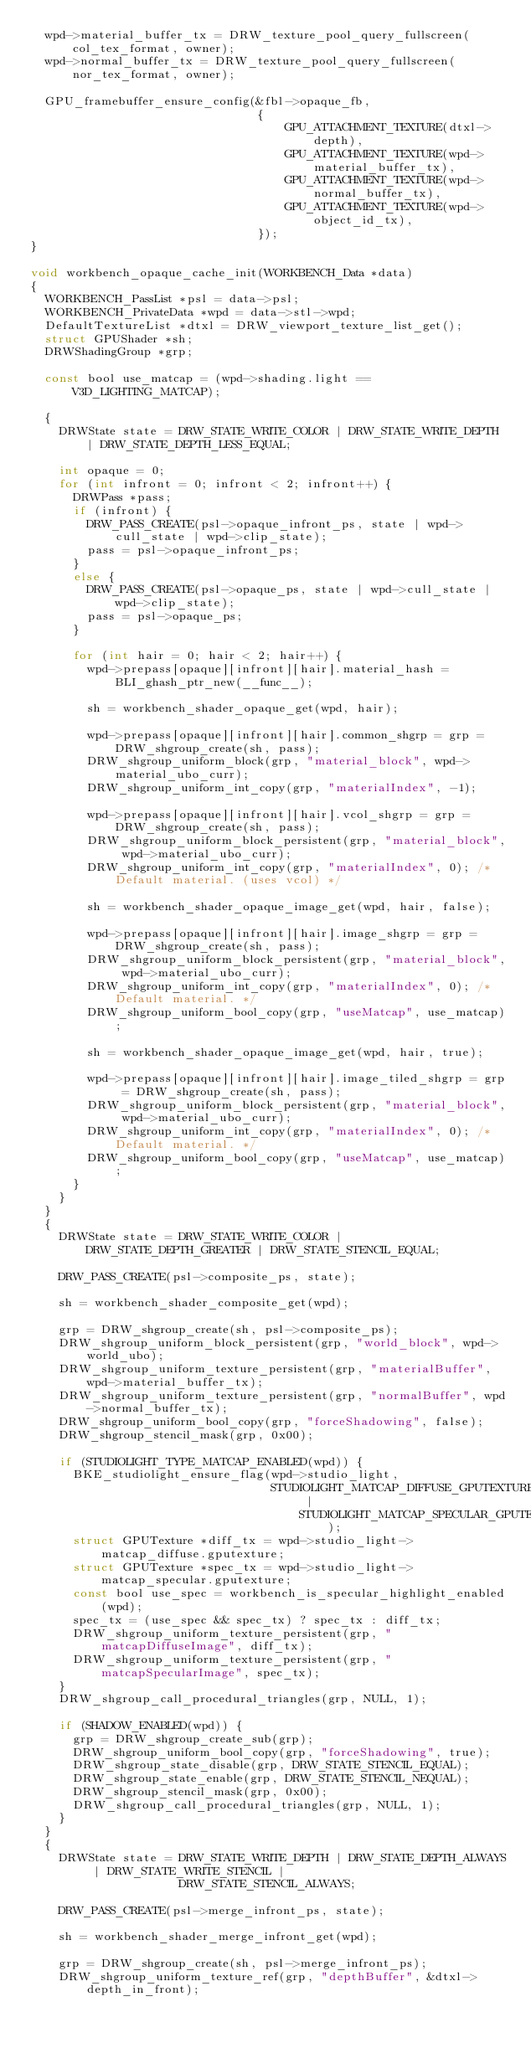<code> <loc_0><loc_0><loc_500><loc_500><_C_>  wpd->material_buffer_tx = DRW_texture_pool_query_fullscreen(col_tex_format, owner);
  wpd->normal_buffer_tx = DRW_texture_pool_query_fullscreen(nor_tex_format, owner);

  GPU_framebuffer_ensure_config(&fbl->opaque_fb,
                                {
                                    GPU_ATTACHMENT_TEXTURE(dtxl->depth),
                                    GPU_ATTACHMENT_TEXTURE(wpd->material_buffer_tx),
                                    GPU_ATTACHMENT_TEXTURE(wpd->normal_buffer_tx),
                                    GPU_ATTACHMENT_TEXTURE(wpd->object_id_tx),
                                });
}

void workbench_opaque_cache_init(WORKBENCH_Data *data)
{
  WORKBENCH_PassList *psl = data->psl;
  WORKBENCH_PrivateData *wpd = data->stl->wpd;
  DefaultTextureList *dtxl = DRW_viewport_texture_list_get();
  struct GPUShader *sh;
  DRWShadingGroup *grp;

  const bool use_matcap = (wpd->shading.light == V3D_LIGHTING_MATCAP);

  {
    DRWState state = DRW_STATE_WRITE_COLOR | DRW_STATE_WRITE_DEPTH | DRW_STATE_DEPTH_LESS_EQUAL;

    int opaque = 0;
    for (int infront = 0; infront < 2; infront++) {
      DRWPass *pass;
      if (infront) {
        DRW_PASS_CREATE(psl->opaque_infront_ps, state | wpd->cull_state | wpd->clip_state);
        pass = psl->opaque_infront_ps;
      }
      else {
        DRW_PASS_CREATE(psl->opaque_ps, state | wpd->cull_state | wpd->clip_state);
        pass = psl->opaque_ps;
      }

      for (int hair = 0; hair < 2; hair++) {
        wpd->prepass[opaque][infront][hair].material_hash = BLI_ghash_ptr_new(__func__);

        sh = workbench_shader_opaque_get(wpd, hair);

        wpd->prepass[opaque][infront][hair].common_shgrp = grp = DRW_shgroup_create(sh, pass);
        DRW_shgroup_uniform_block(grp, "material_block", wpd->material_ubo_curr);
        DRW_shgroup_uniform_int_copy(grp, "materialIndex", -1);

        wpd->prepass[opaque][infront][hair].vcol_shgrp = grp = DRW_shgroup_create(sh, pass);
        DRW_shgroup_uniform_block_persistent(grp, "material_block", wpd->material_ubo_curr);
        DRW_shgroup_uniform_int_copy(grp, "materialIndex", 0); /* Default material. (uses vcol) */

        sh = workbench_shader_opaque_image_get(wpd, hair, false);

        wpd->prepass[opaque][infront][hair].image_shgrp = grp = DRW_shgroup_create(sh, pass);
        DRW_shgroup_uniform_block_persistent(grp, "material_block", wpd->material_ubo_curr);
        DRW_shgroup_uniform_int_copy(grp, "materialIndex", 0); /* Default material. */
        DRW_shgroup_uniform_bool_copy(grp, "useMatcap", use_matcap);

        sh = workbench_shader_opaque_image_get(wpd, hair, true);

        wpd->prepass[opaque][infront][hair].image_tiled_shgrp = grp = DRW_shgroup_create(sh, pass);
        DRW_shgroup_uniform_block_persistent(grp, "material_block", wpd->material_ubo_curr);
        DRW_shgroup_uniform_int_copy(grp, "materialIndex", 0); /* Default material. */
        DRW_shgroup_uniform_bool_copy(grp, "useMatcap", use_matcap);
      }
    }
  }
  {
    DRWState state = DRW_STATE_WRITE_COLOR | DRW_STATE_DEPTH_GREATER | DRW_STATE_STENCIL_EQUAL;

    DRW_PASS_CREATE(psl->composite_ps, state);

    sh = workbench_shader_composite_get(wpd);

    grp = DRW_shgroup_create(sh, psl->composite_ps);
    DRW_shgroup_uniform_block_persistent(grp, "world_block", wpd->world_ubo);
    DRW_shgroup_uniform_texture_persistent(grp, "materialBuffer", wpd->material_buffer_tx);
    DRW_shgroup_uniform_texture_persistent(grp, "normalBuffer", wpd->normal_buffer_tx);
    DRW_shgroup_uniform_bool_copy(grp, "forceShadowing", false);
    DRW_shgroup_stencil_mask(grp, 0x00);

    if (STUDIOLIGHT_TYPE_MATCAP_ENABLED(wpd)) {
      BKE_studiolight_ensure_flag(wpd->studio_light,
                                  STUDIOLIGHT_MATCAP_DIFFUSE_GPUTEXTURE |
                                      STUDIOLIGHT_MATCAP_SPECULAR_GPUTEXTURE);
      struct GPUTexture *diff_tx = wpd->studio_light->matcap_diffuse.gputexture;
      struct GPUTexture *spec_tx = wpd->studio_light->matcap_specular.gputexture;
      const bool use_spec = workbench_is_specular_highlight_enabled(wpd);
      spec_tx = (use_spec && spec_tx) ? spec_tx : diff_tx;
      DRW_shgroup_uniform_texture_persistent(grp, "matcapDiffuseImage", diff_tx);
      DRW_shgroup_uniform_texture_persistent(grp, "matcapSpecularImage", spec_tx);
    }
    DRW_shgroup_call_procedural_triangles(grp, NULL, 1);

    if (SHADOW_ENABLED(wpd)) {
      grp = DRW_shgroup_create_sub(grp);
      DRW_shgroup_uniform_bool_copy(grp, "forceShadowing", true);
      DRW_shgroup_state_disable(grp, DRW_STATE_STENCIL_EQUAL);
      DRW_shgroup_state_enable(grp, DRW_STATE_STENCIL_NEQUAL);
      DRW_shgroup_stencil_mask(grp, 0x00);
      DRW_shgroup_call_procedural_triangles(grp, NULL, 1);
    }
  }
  {
    DRWState state = DRW_STATE_WRITE_DEPTH | DRW_STATE_DEPTH_ALWAYS | DRW_STATE_WRITE_STENCIL |
                     DRW_STATE_STENCIL_ALWAYS;

    DRW_PASS_CREATE(psl->merge_infront_ps, state);

    sh = workbench_shader_merge_infront_get(wpd);

    grp = DRW_shgroup_create(sh, psl->merge_infront_ps);
    DRW_shgroup_uniform_texture_ref(grp, "depthBuffer", &dtxl->depth_in_front);</code> 